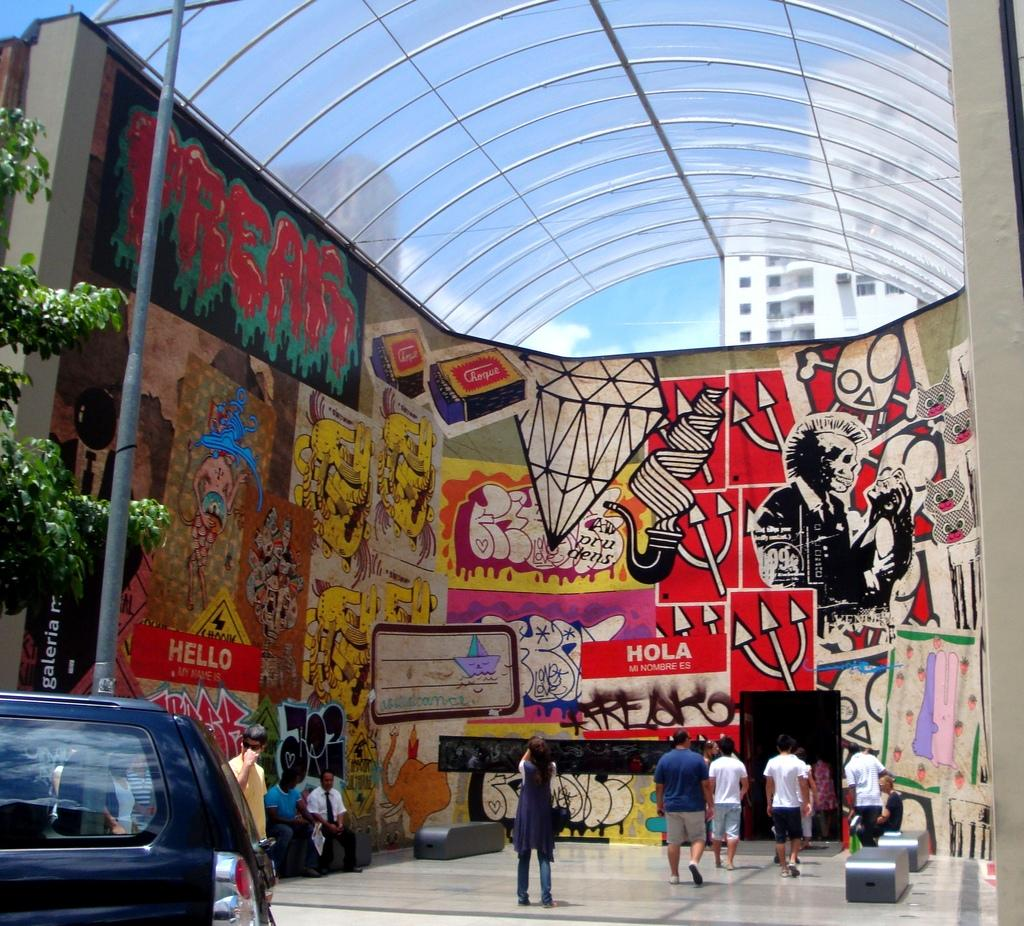Provide a one-sentence caption for the provided image. A wall filled with art, and sings that say both Hello and Hola. 